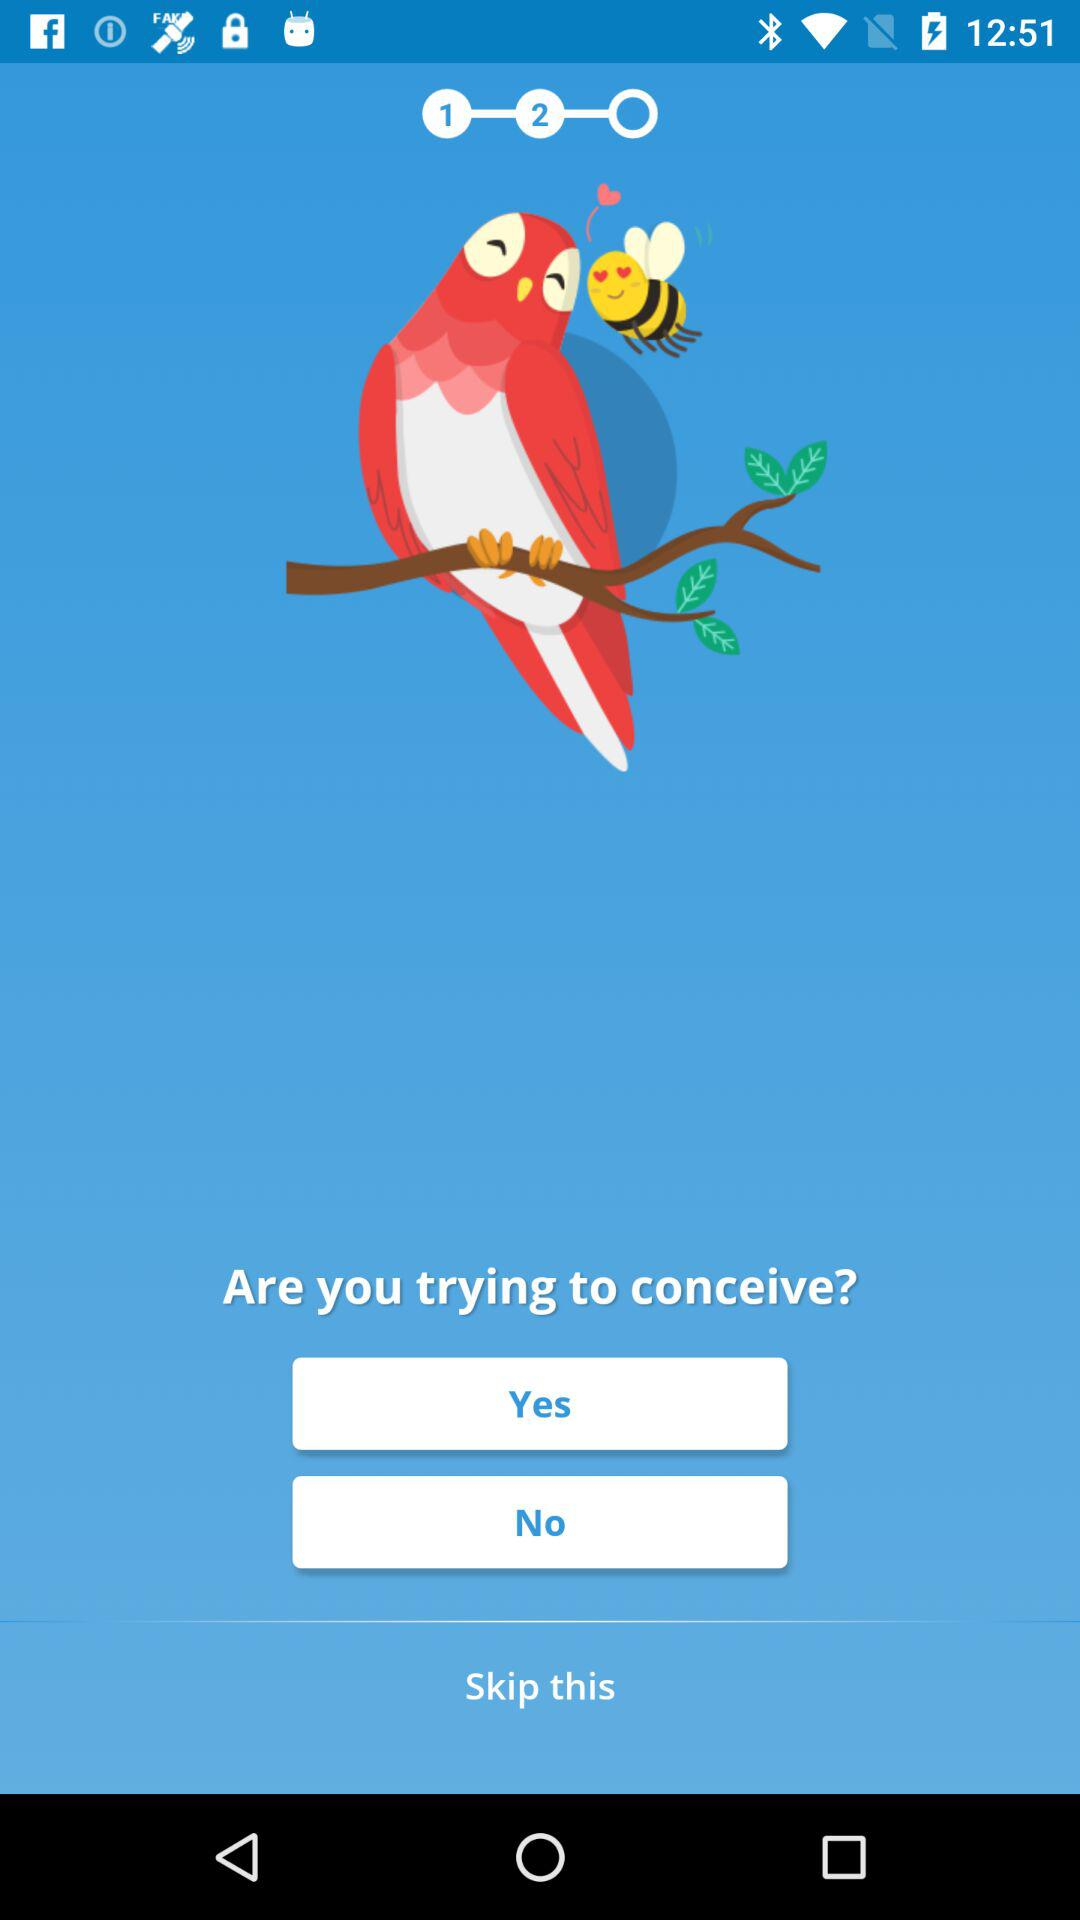Which step number are we currently on? You are currently on the second step number. 